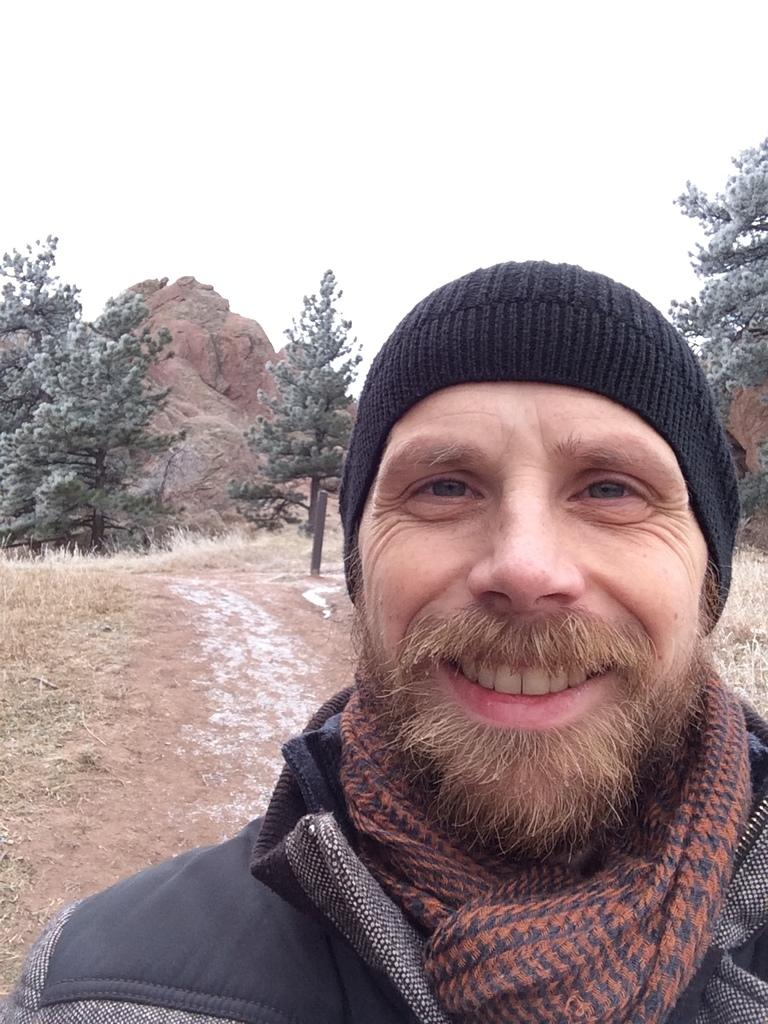Who is present in the image? There is a man in the image. What is the man wearing on his head? The man is wearing a black cap. What can be seen in the background of the image? There are trees and rocks in the background of the image. What is visible at the top of the image? The sky is visible at the top of the image. What type of terrain is visible at the bottom of the image? There is land and grass visible at the bottom of the image. What type of pets can be seen playing with soap in the image? There are no pets or soap present in the image; it features a man wearing a black cap with a background of trees, rocks, sky, and grass. 